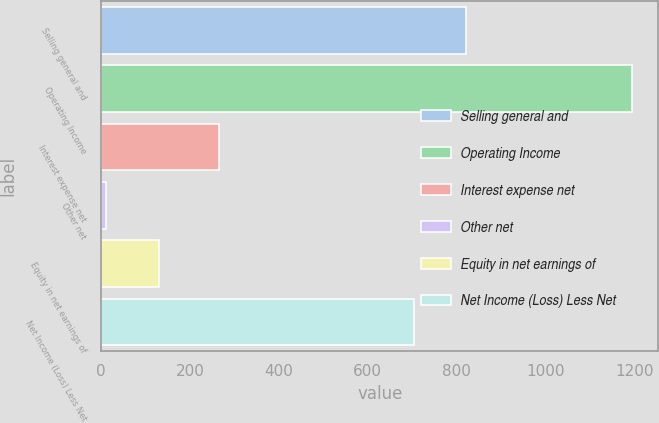Convert chart. <chart><loc_0><loc_0><loc_500><loc_500><bar_chart><fcel>Selling general and<fcel>Operating Income<fcel>Interest expense net<fcel>Other net<fcel>Equity in net earnings of<fcel>Net Income (Loss) Less Net<nl><fcel>821.2<fcel>1194<fcel>265<fcel>12<fcel>130.2<fcel>703<nl></chart> 